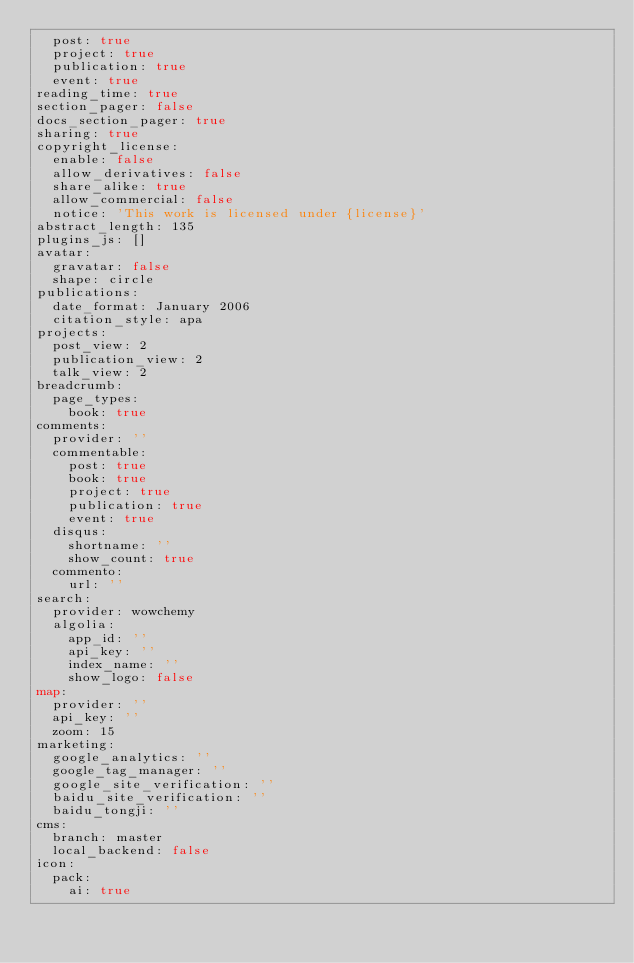Convert code to text. <code><loc_0><loc_0><loc_500><loc_500><_YAML_>  post: true
  project: true
  publication: true
  event: true
reading_time: true
section_pager: false
docs_section_pager: true
sharing: true
copyright_license:
  enable: false
  allow_derivatives: false
  share_alike: true
  allow_commercial: false
  notice: 'This work is licensed under {license}'
abstract_length: 135
plugins_js: []
avatar:
  gravatar: false
  shape: circle
publications:
  date_format: January 2006
  citation_style: apa
projects:
  post_view: 2
  publication_view: 2
  talk_view: 2
breadcrumb:
  page_types:
    book: true
comments:
  provider: ''
  commentable:
    post: true
    book: true
    project: true
    publication: true
    event: true
  disqus:
    shortname: ''
    show_count: true
  commento:
    url: ''
search:
  provider: wowchemy
  algolia:
    app_id: ''
    api_key: ''
    index_name: ''
    show_logo: false
map:
  provider: ''
  api_key: ''
  zoom: 15
marketing:
  google_analytics: ''
  google_tag_manager: ''
  google_site_verification: ''
  baidu_site_verification: ''
  baidu_tongji: ''
cms:
  branch: master
  local_backend: false
icon:
  pack:
    ai: true
</code> 